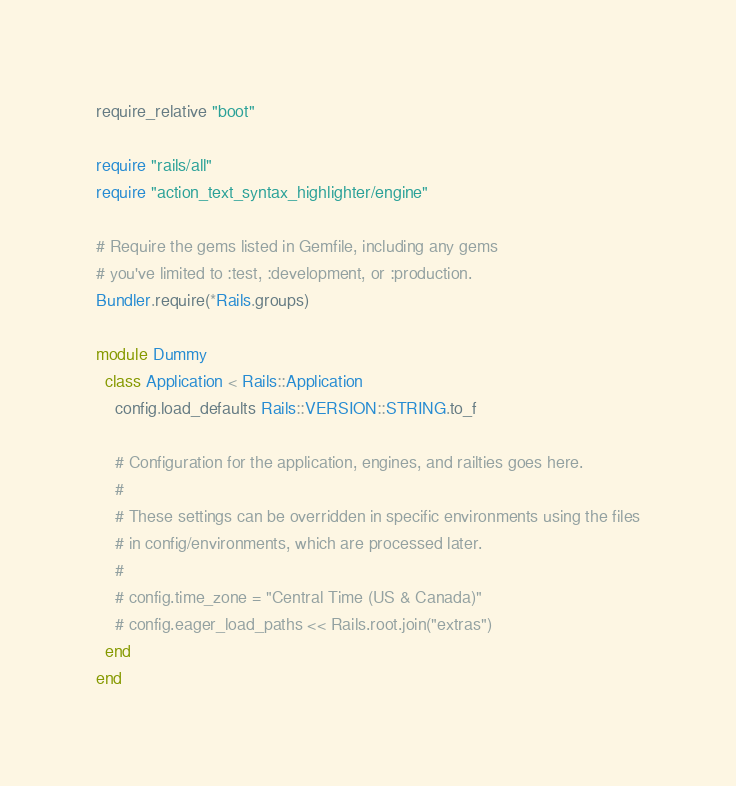<code> <loc_0><loc_0><loc_500><loc_500><_Ruby_>require_relative "boot"

require "rails/all"
require "action_text_syntax_highlighter/engine"

# Require the gems listed in Gemfile, including any gems
# you've limited to :test, :development, or :production.
Bundler.require(*Rails.groups)

module Dummy
  class Application < Rails::Application
    config.load_defaults Rails::VERSION::STRING.to_f

    # Configuration for the application, engines, and railties goes here.
    #
    # These settings can be overridden in specific environments using the files
    # in config/environments, which are processed later.
    #
    # config.time_zone = "Central Time (US & Canada)"
    # config.eager_load_paths << Rails.root.join("extras")
  end
end
</code> 